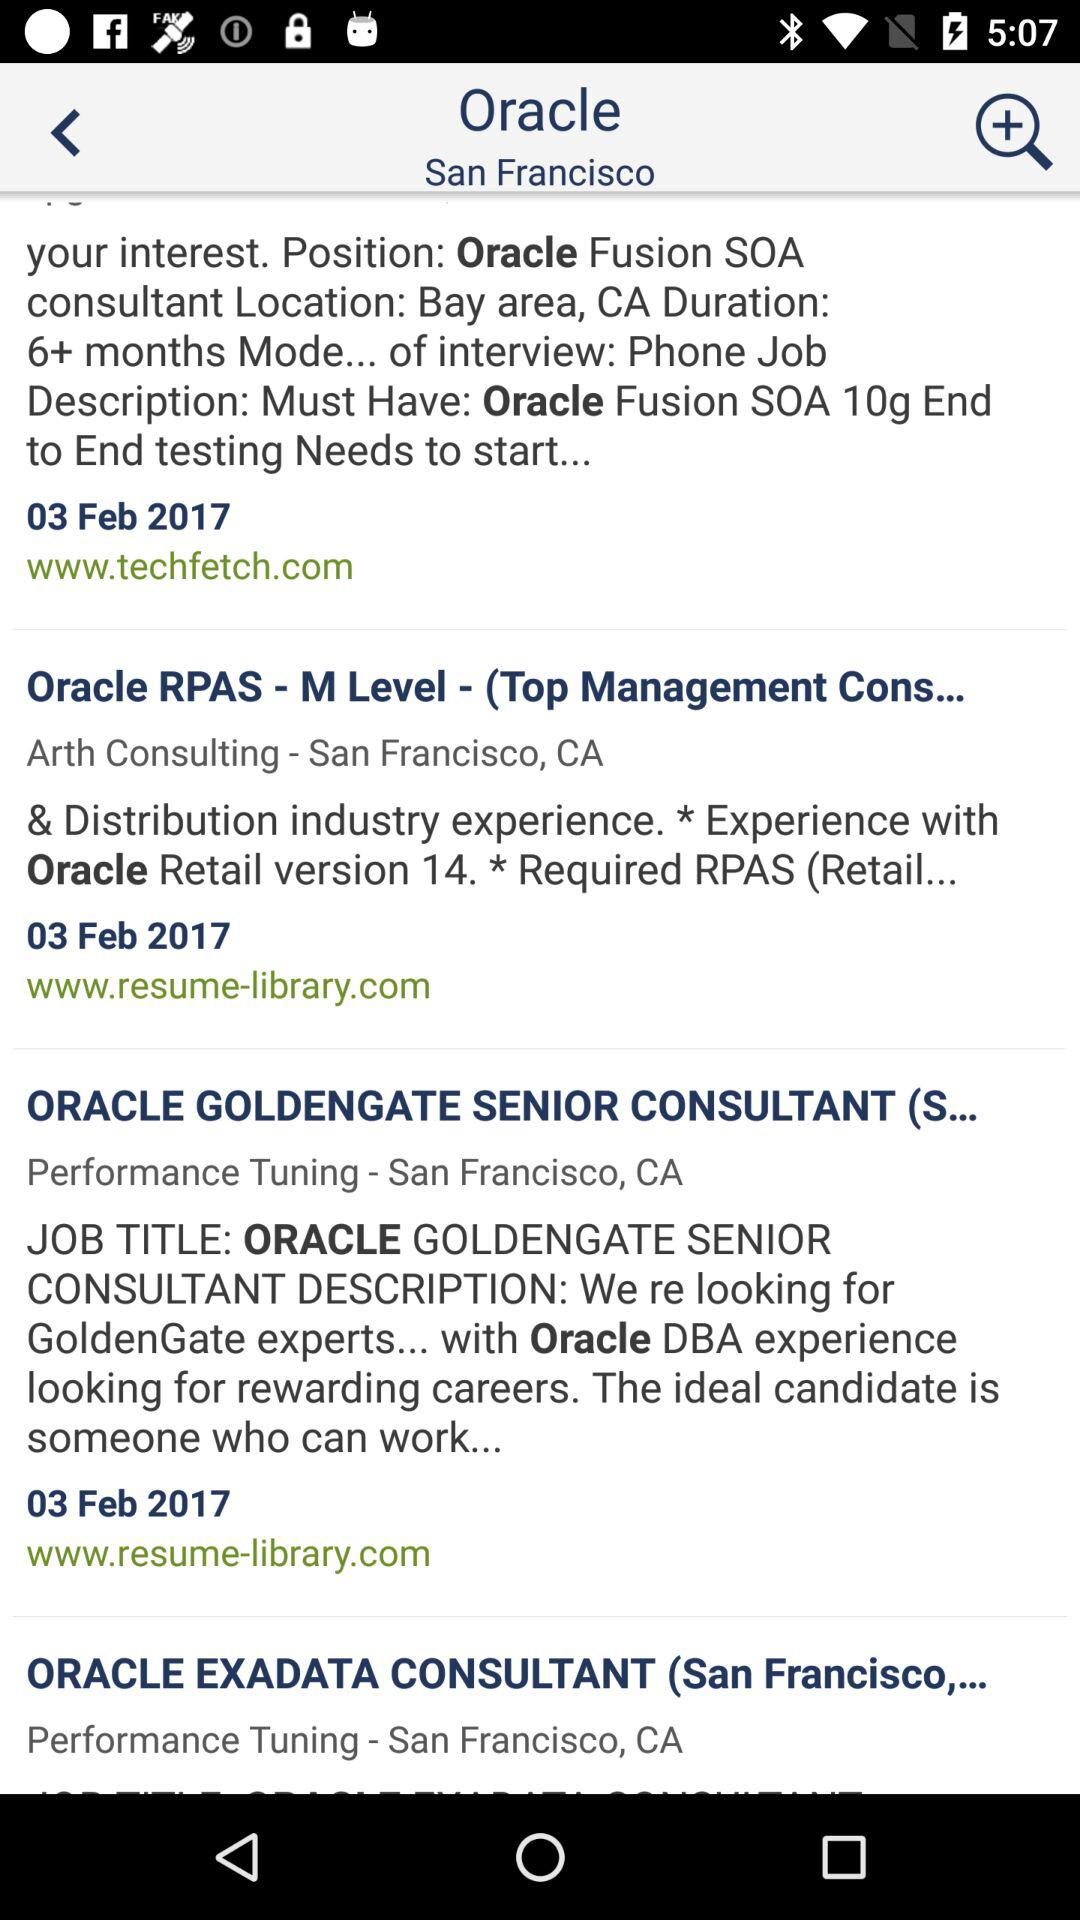What is the CA time duration for Oracle Fusion SOA? The CA time duration for Oracle Fusion SOA is 6+ months. 